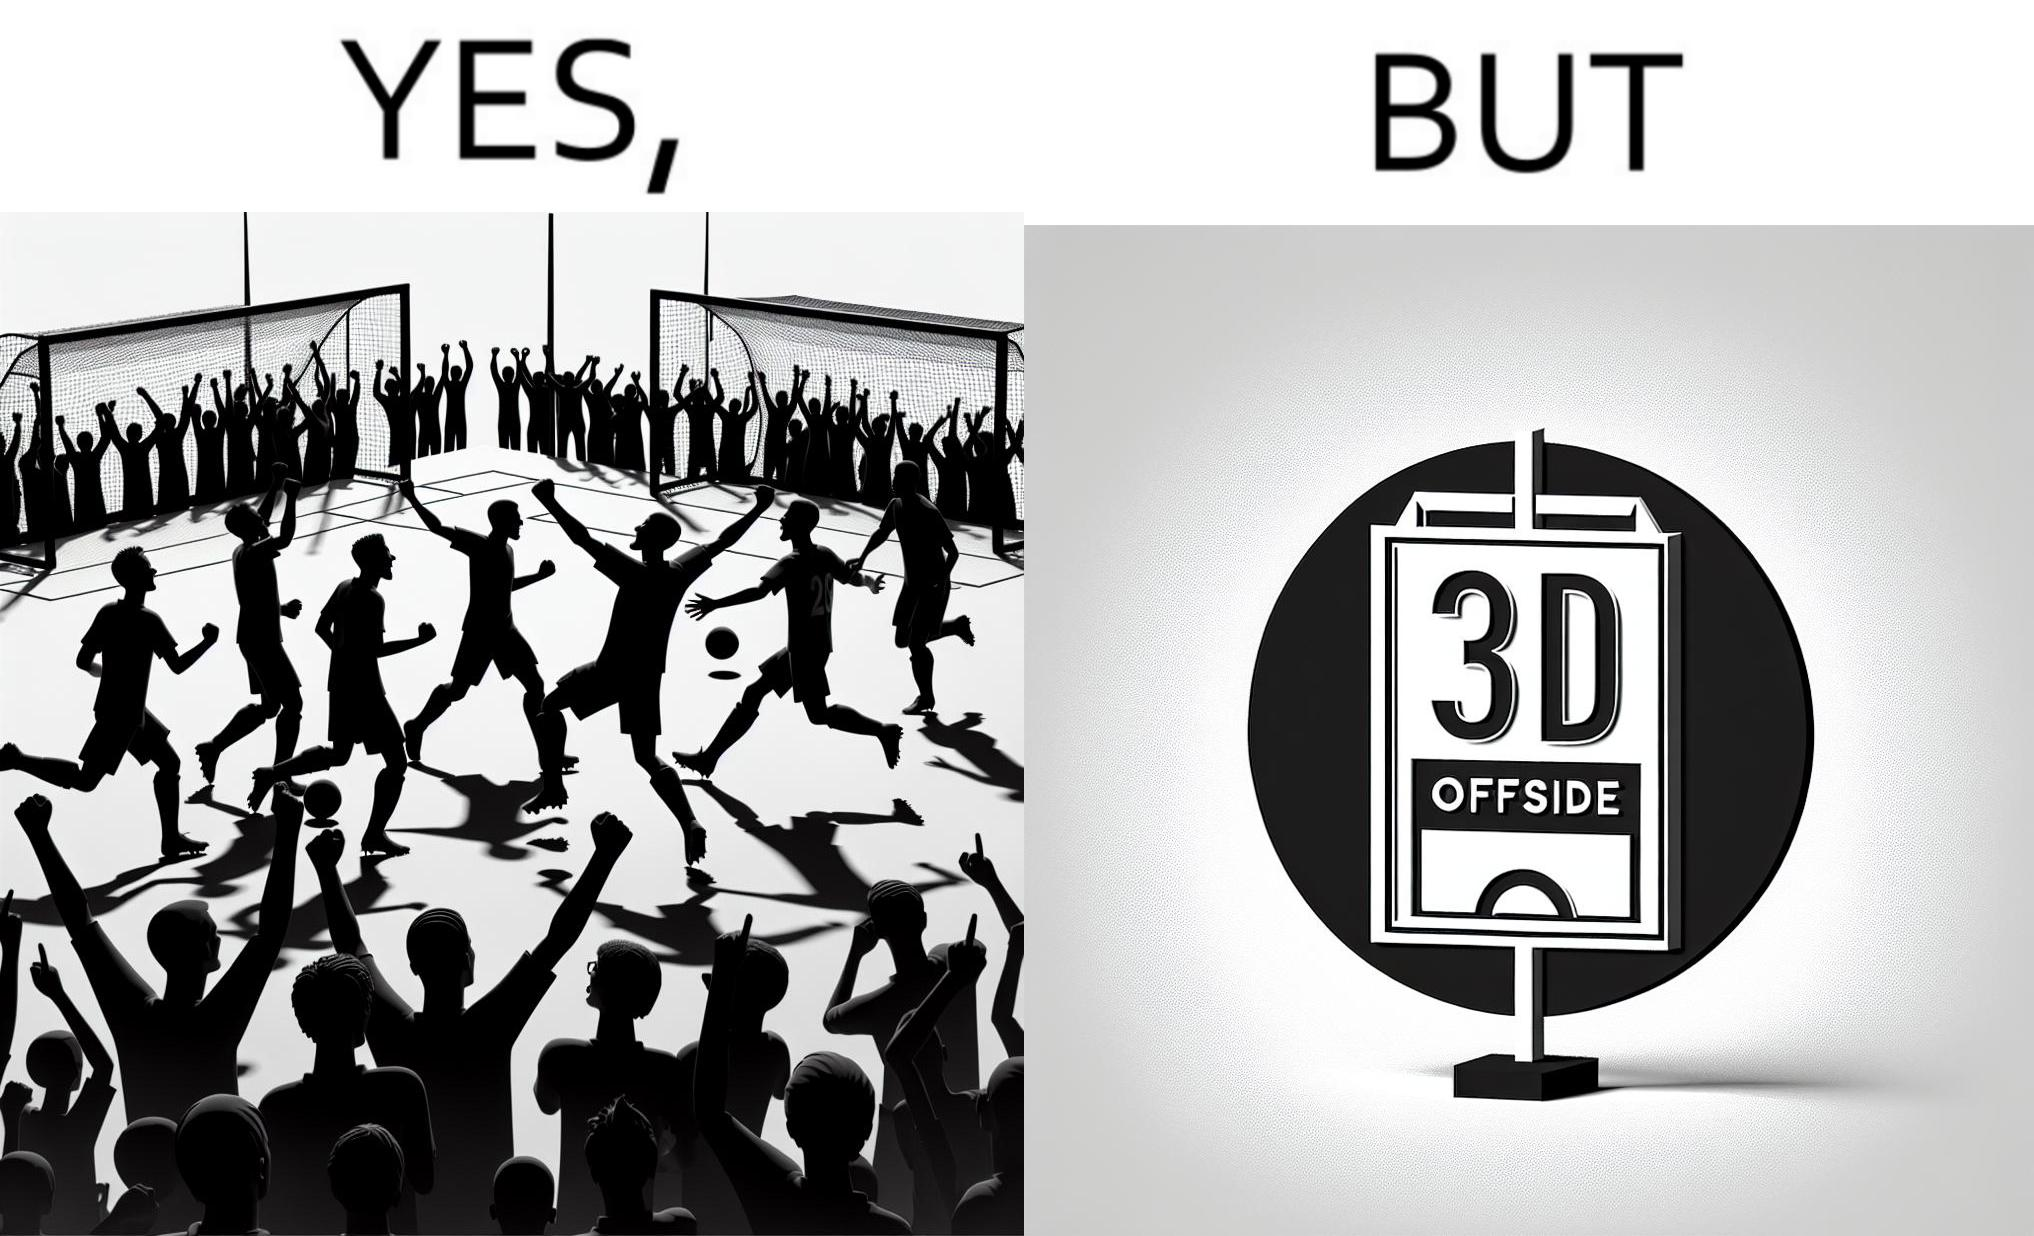What do you see in each half of this image? In the left part of the image: football players celebrating, probably due a goal their team has scored. In the right part of the image: A sign of "No goal - Offside". 